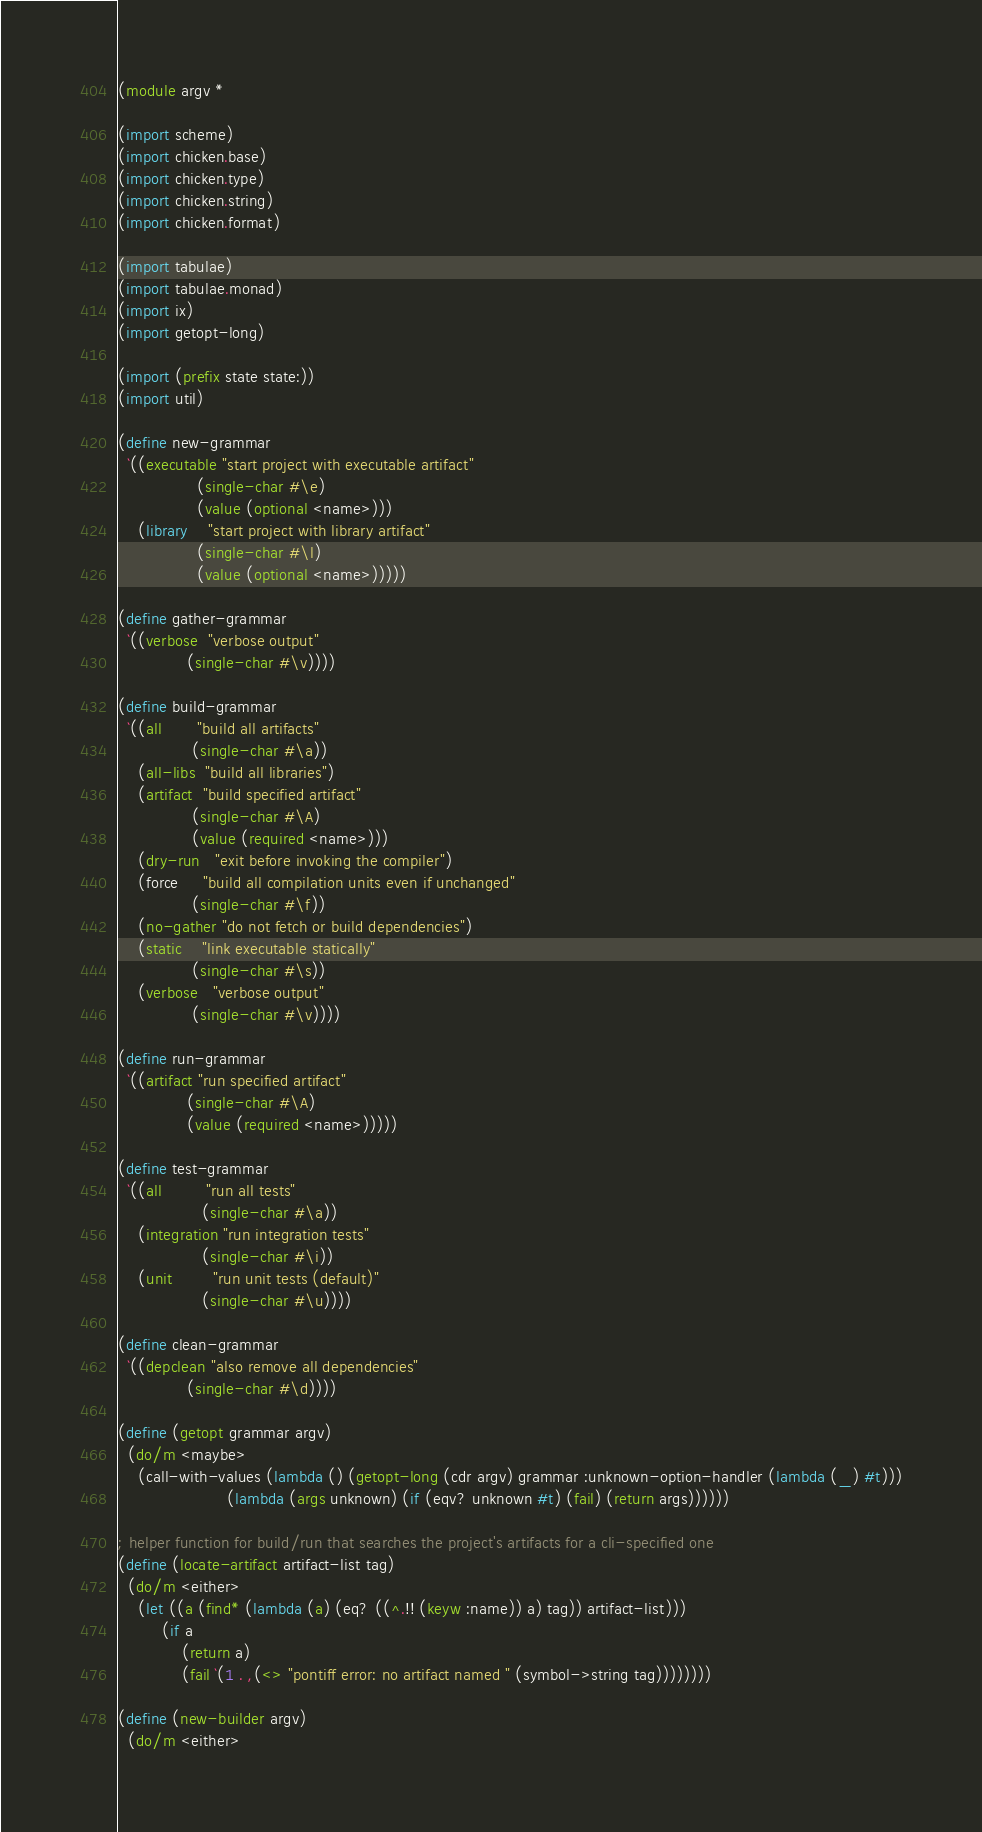Convert code to text. <code><loc_0><loc_0><loc_500><loc_500><_Scheme_>(module argv *

(import scheme)
(import chicken.base)
(import chicken.type)
(import chicken.string)
(import chicken.format)

(import tabulae)
(import tabulae.monad)
(import ix)
(import getopt-long)

(import (prefix state state:))
(import util)

(define new-grammar
  `((executable "start project with executable artifact"
                (single-char #\e)
                (value (optional <name>)))
    (library    "start project with library artifact"
                (single-char #\l)
                (value (optional <name>)))))

(define gather-grammar
  `((verbose  "verbose output"
              (single-char #\v))))

(define build-grammar
  `((all       "build all artifacts"
               (single-char #\a))
    (all-libs  "build all libraries")
    (artifact  "build specified artifact"
               (single-char #\A)
               (value (required <name>)))
    (dry-run   "exit before invoking the compiler")
    (force     "build all compilation units even if unchanged"
               (single-char #\f))
    (no-gather "do not fetch or build dependencies")
    (static    "link executable statically"
               (single-char #\s))
    (verbose   "verbose output"
               (single-char #\v))))

(define run-grammar
  `((artifact "run specified artifact"
              (single-char #\A)
              (value (required <name>)))))

(define test-grammar
  `((all         "run all tests"
                 (single-char #\a))
    (integration "run integration tests"
                 (single-char #\i))
    (unit        "run unit tests (default)"
                 (single-char #\u))))

(define clean-grammar
  `((depclean "also remove all dependencies"
              (single-char #\d))))

(define (getopt grammar argv)
  (do/m <maybe>
    (call-with-values (lambda () (getopt-long (cdr argv) grammar :unknown-option-handler (lambda (_) #t)))
                      (lambda (args unknown) (if (eqv? unknown #t) (fail) (return args))))))

; helper function for build/run that searches the project's artifacts for a cli-specified one
(define (locate-artifact artifact-list tag)
  (do/m <either>
    (let ((a (find* (lambda (a) (eq? ((^.!! (keyw :name)) a) tag)) artifact-list)))
         (if a
             (return a)
             (fail `(1 . ,(<> "pontiff error: no artifact named " (symbol->string tag))))))))

(define (new-builder argv)
  (do/m <either></code> 